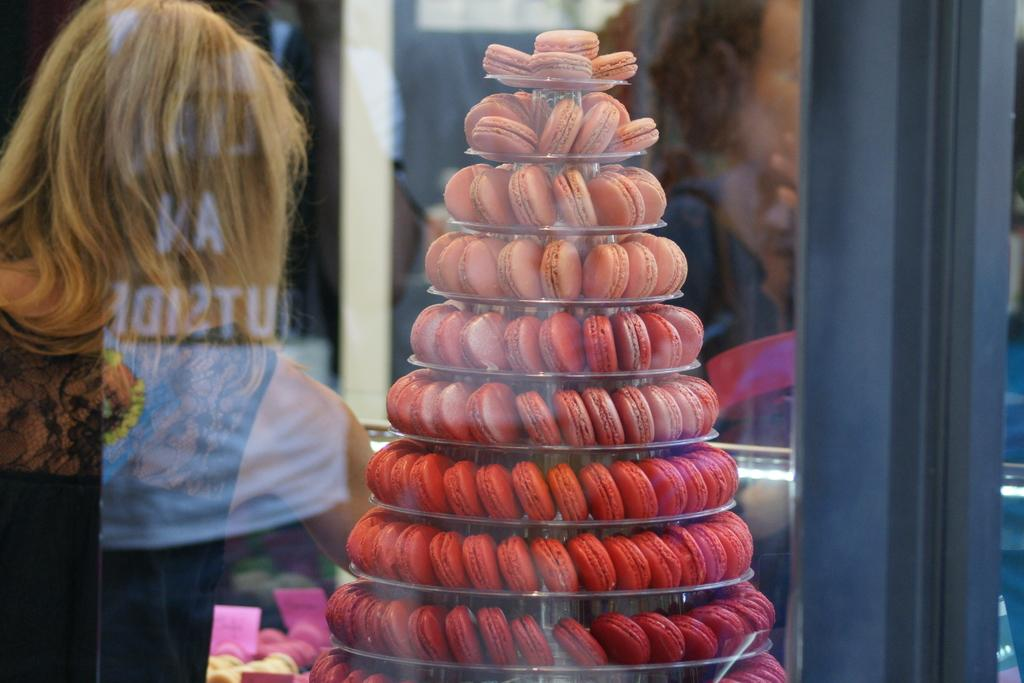Who is present in the image? There is a woman in the image. What can be seen on the cake stand in the image? There are muffins placed on a cake stand in the image. What type of wire is used to hold the muffins together in the image? There is no wire present in the image; the muffins are placed on a cake stand. What is the copper content of the muffins in the image? There is no copper content in the muffins, as they are a baked good and not a metal. 